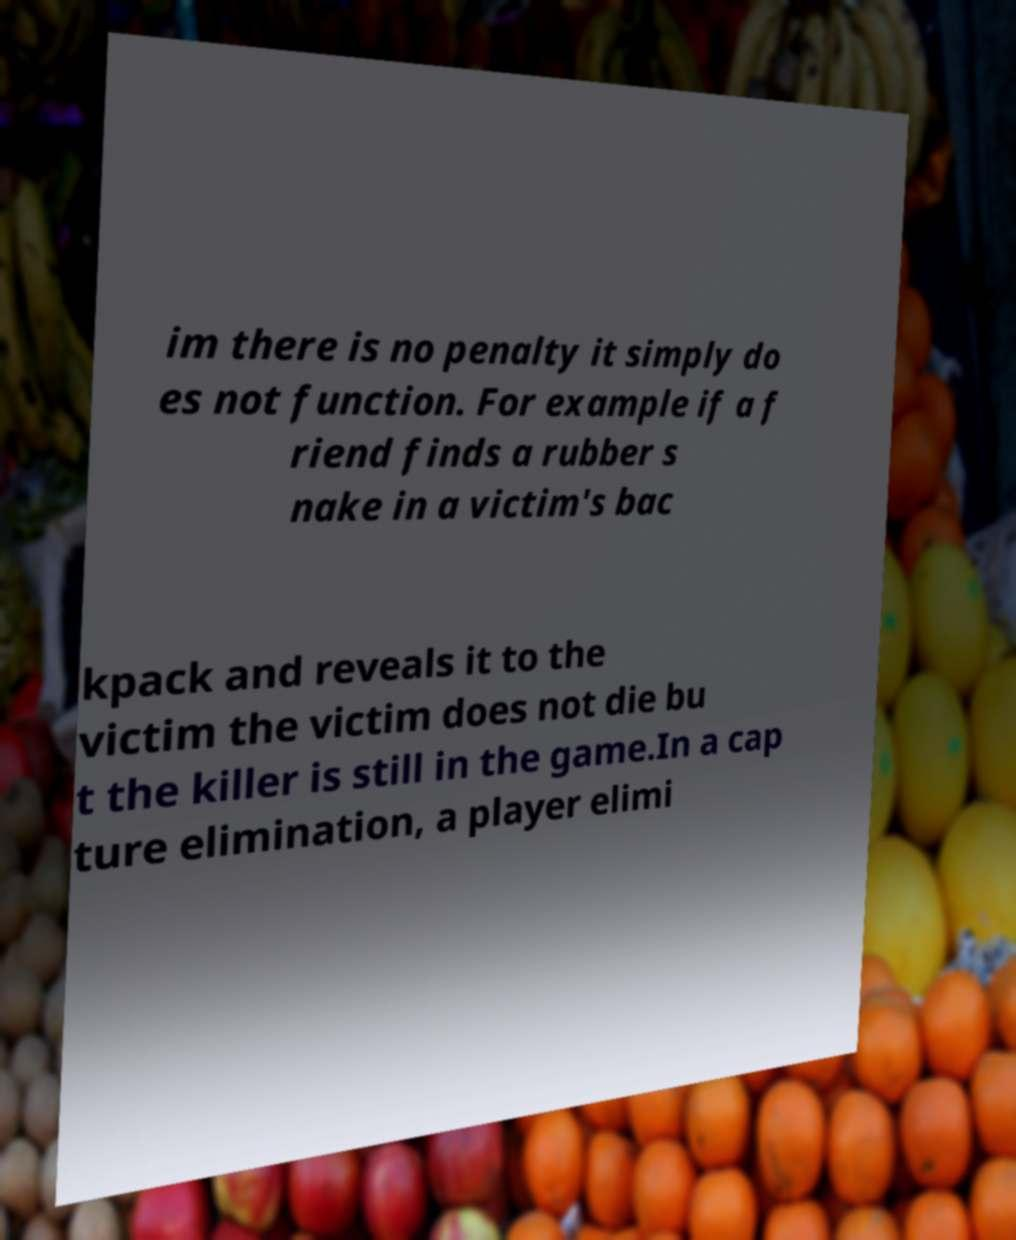I need the written content from this picture converted into text. Can you do that? im there is no penalty it simply do es not function. For example if a f riend finds a rubber s nake in a victim's bac kpack and reveals it to the victim the victim does not die bu t the killer is still in the game.In a cap ture elimination, a player elimi 